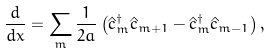<formula> <loc_0><loc_0><loc_500><loc_500>\frac { d } { d x } = \sum _ { m } \frac { 1 } { 2 a } \left ( \hat { c } _ { m } ^ { \dagger } \hat { c } _ { m + 1 } - \hat { c } _ { m } ^ { \dagger } \hat { c } _ { m - 1 } \right ) ,</formula> 